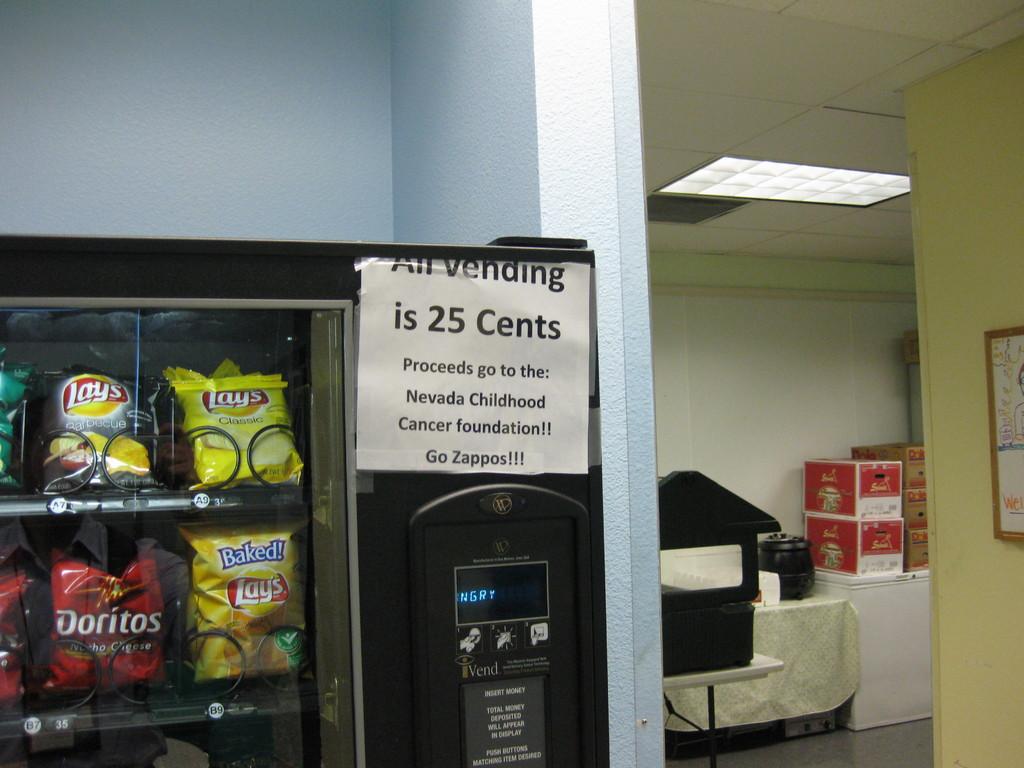Where do the proceeds go?
Keep it short and to the point. Nevada childhood cancer foundation. How much is it?
Provide a short and direct response. 25 cents. 